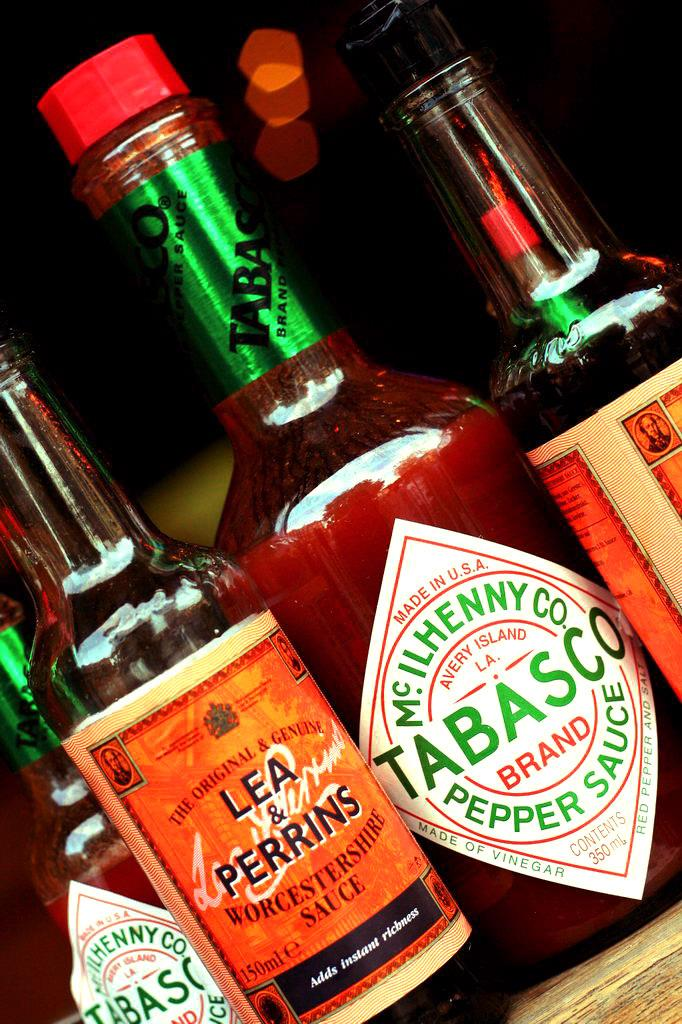<image>
Render a clear and concise summary of the photo. Two bottles of Tabasco hot sauce are on a table next to two bottles of Lea & Perrins Worcestershire Sauce. 